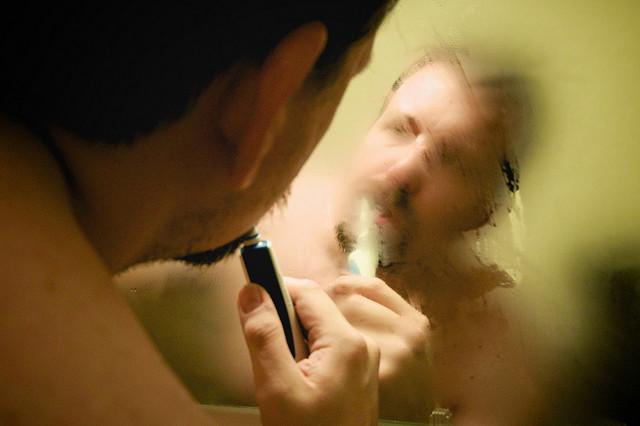Is this man shaving or brushing his teeth?
Concise answer only. Brushing his teeth. Could the mirror be steamed up?
Quick response, please. Yes. Is this a bathroom or kitchen?
Concise answer only. Bathroom. 